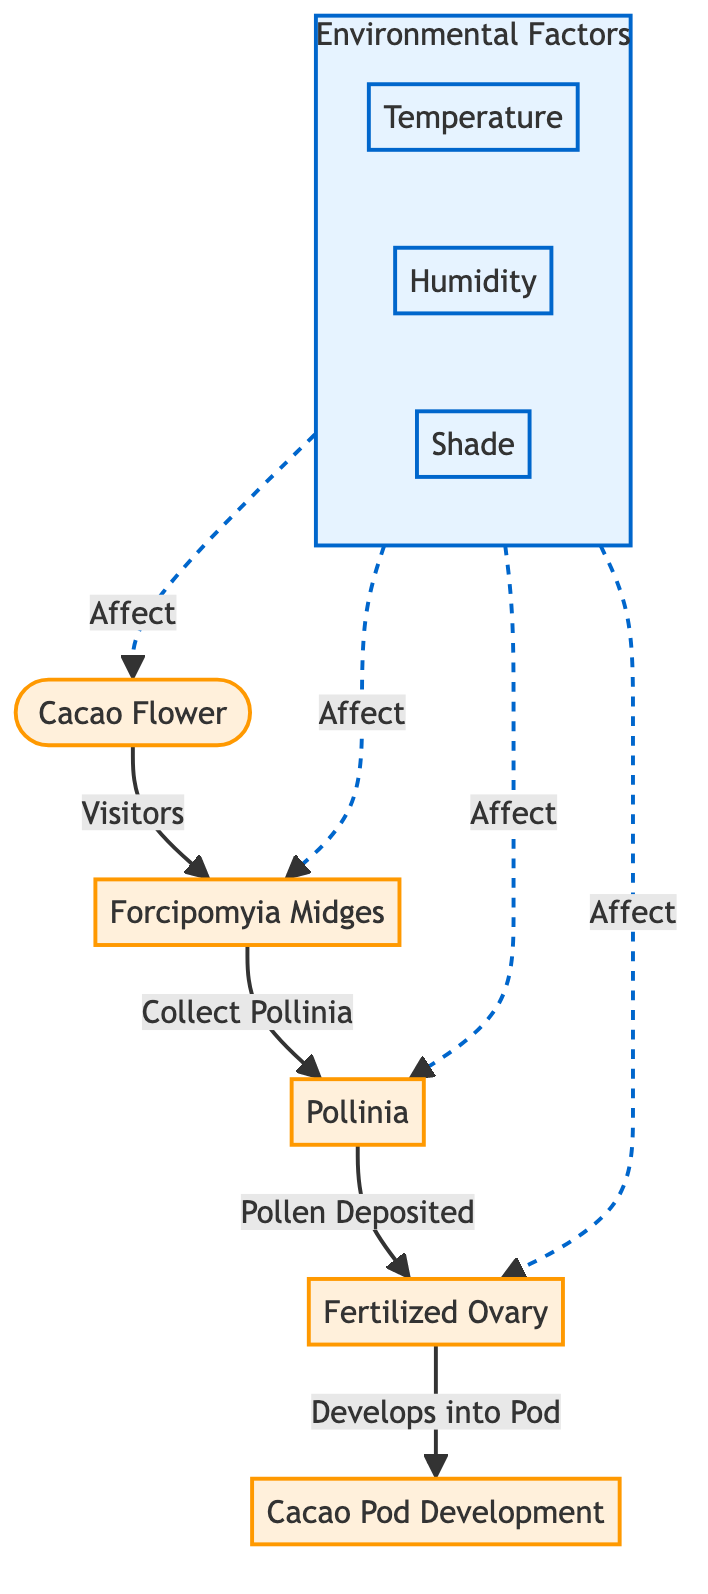What is the first step in the pollination process? The first step is represented by the arrow leading from the "Cacao Flower" to "Forcipomyia Midges", indicating that midges visit the cacao flower.
Answer: Forcipomyia Midges How many environmental factors are listed in the diagram? The diagram contains three environmental factors: temperature, humidity, and shade. By counting the nodes in the "Environmental Factors" section, we find three.
Answer: 3 What do forcipomyia midges collect from the cacao flower? The arrow from "Forcipomyia Midges" to "Pollinia" denotes that they collect pollinia from the flower.
Answer: Pollinia Which factor most directly affects the cacao flower? The dashed line shows the relationship indicating that environmental factors affect the cacao flower. Specifically, the presence of effects marks their interactions.
Answer: Environmental Factors What do fertilized ovaries develop into? The process line from "Fertilized Ovary" indicates that it develops into cacao pods, as shown by the arrow pointing to "Cacao Pod Development".
Answer: Cacao Pod Development How does temperature relate to the pollination process? Temperature is one of the environmental factors that affect various aspects of the pollination process, as shown by the dashed line connecting it to relevant nodes in the diagram.
Answer: Affect In total, how many distinct nodes are shown in the diagram? By counting all the nodes, including the flower, midges, pollinia, fertilized ovary, cacao pod development, and environmental factors, we find there are six distinct nodes.
Answer: 6 What role do environmental factors play in the pollination process? They serve as modifiers or influencers that affect the cacao flower, forcipomyia midges, pollinia, and fertilized ovary, indicated by the dashed lines connecting them.
Answer: Affect What does the pollinia represent in this context? The pollinia represents the pollen collected by midges from the cacao flower, as indicated by the directed arrow from "Forcipomyia Midges" to "Pollinia".
Answer: Pollen 